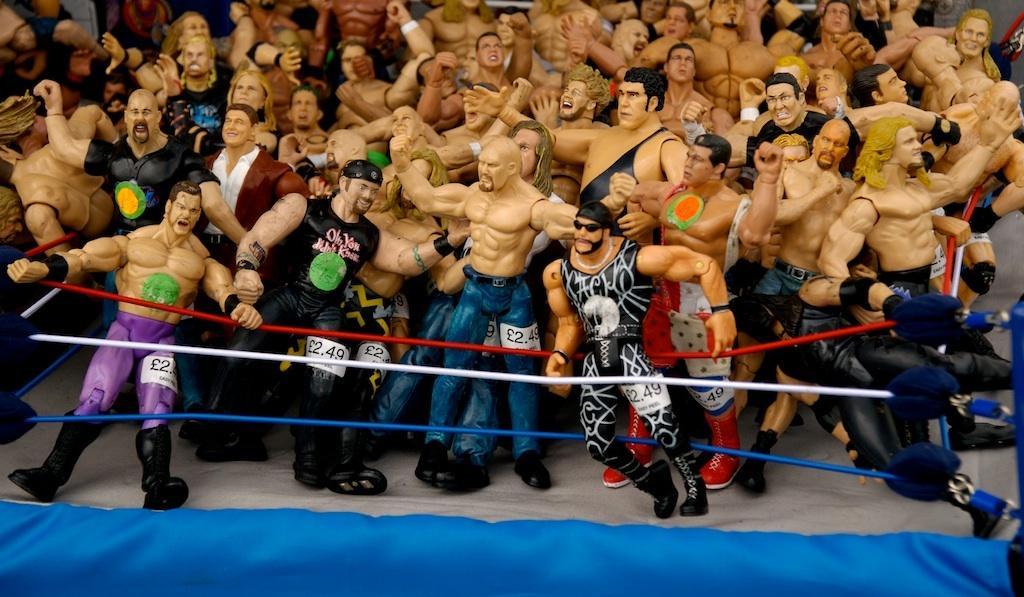Describe this image in one or two sentences. In this image we can see toys and ropes. At the bottom of the image we can see a blue color object. 